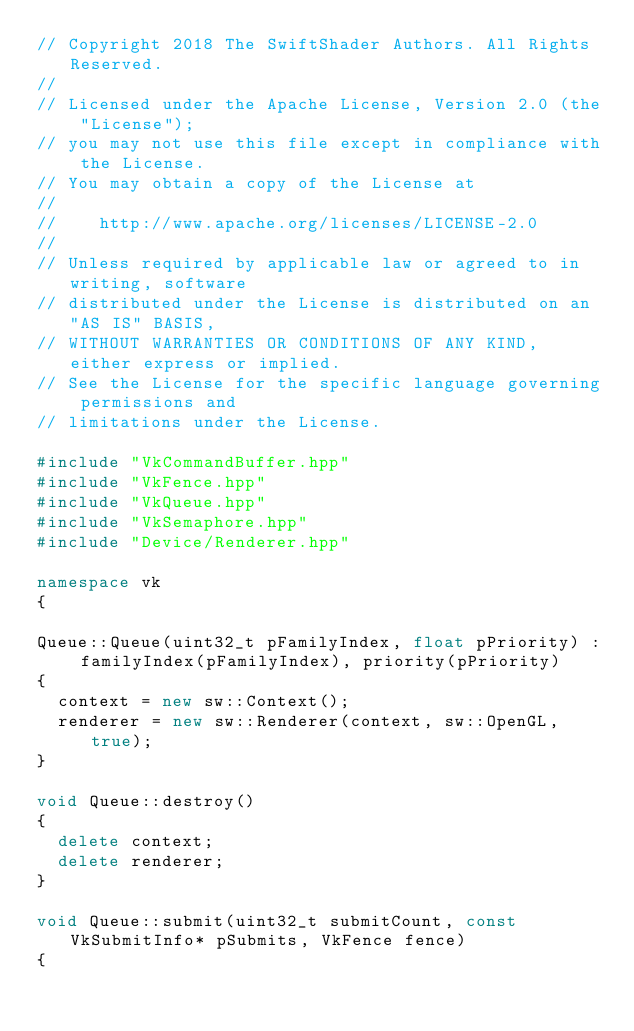Convert code to text. <code><loc_0><loc_0><loc_500><loc_500><_C++_>// Copyright 2018 The SwiftShader Authors. All Rights Reserved.
//
// Licensed under the Apache License, Version 2.0 (the "License");
// you may not use this file except in compliance with the License.
// You may obtain a copy of the License at
//
//    http://www.apache.org/licenses/LICENSE-2.0
//
// Unless required by applicable law or agreed to in writing, software
// distributed under the License is distributed on an "AS IS" BASIS,
// WITHOUT WARRANTIES OR CONDITIONS OF ANY KIND, either express or implied.
// See the License for the specific language governing permissions and
// limitations under the License.

#include "VkCommandBuffer.hpp"
#include "VkFence.hpp"
#include "VkQueue.hpp"
#include "VkSemaphore.hpp"
#include "Device/Renderer.hpp"

namespace vk
{

Queue::Queue(uint32_t pFamilyIndex, float pPriority) : familyIndex(pFamilyIndex), priority(pPriority)
{
	context = new sw::Context();
	renderer = new sw::Renderer(context, sw::OpenGL, true);
}

void Queue::destroy()
{
	delete context;
	delete renderer;
}

void Queue::submit(uint32_t submitCount, const VkSubmitInfo* pSubmits, VkFence fence)
{</code> 